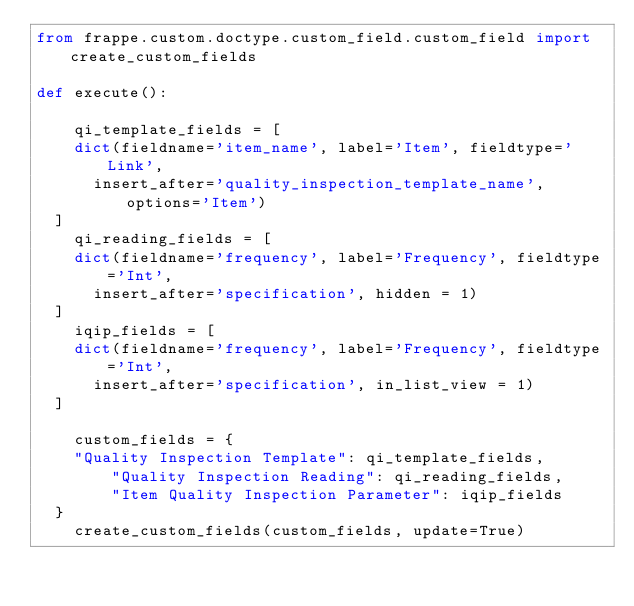<code> <loc_0><loc_0><loc_500><loc_500><_Python_>from frappe.custom.doctype.custom_field.custom_field import create_custom_fields

def execute():

    qi_template_fields = [
		dict(fieldname='item_name', label='Item', fieldtype='Link',
			insert_after='quality_inspection_template_name', options='Item')
	]
    qi_reading_fields = [
		dict(fieldname='frequency', label='Frequency', fieldtype='Int',
			insert_after='specification', hidden = 1)
	]
    iqip_fields = [
		dict(fieldname='frequency', label='Frequency', fieldtype='Int',
			insert_after='specification', in_list_view = 1)
	]

    custom_fields = {
		"Quality Inspection Template": qi_template_fields,
        "Quality Inspection Reading": qi_reading_fields,
        "Item Quality Inspection Parameter": iqip_fields
	}
    create_custom_fields(custom_fields, update=True)

</code> 